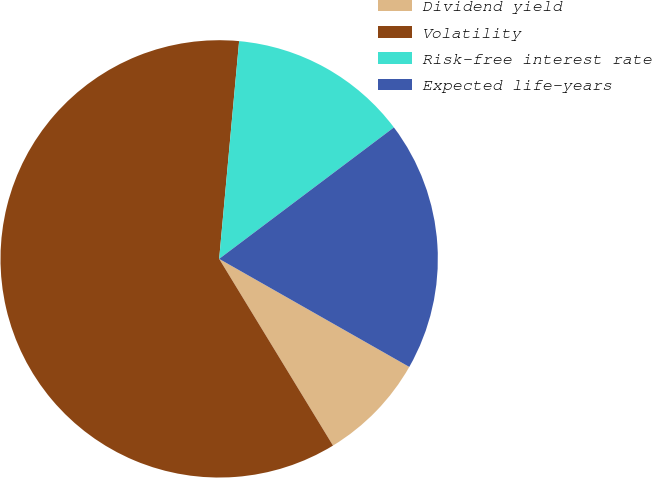<chart> <loc_0><loc_0><loc_500><loc_500><pie_chart><fcel>Dividend yield<fcel>Volatility<fcel>Risk-free interest rate<fcel>Expected life-years<nl><fcel>8.06%<fcel>60.17%<fcel>13.28%<fcel>18.49%<nl></chart> 